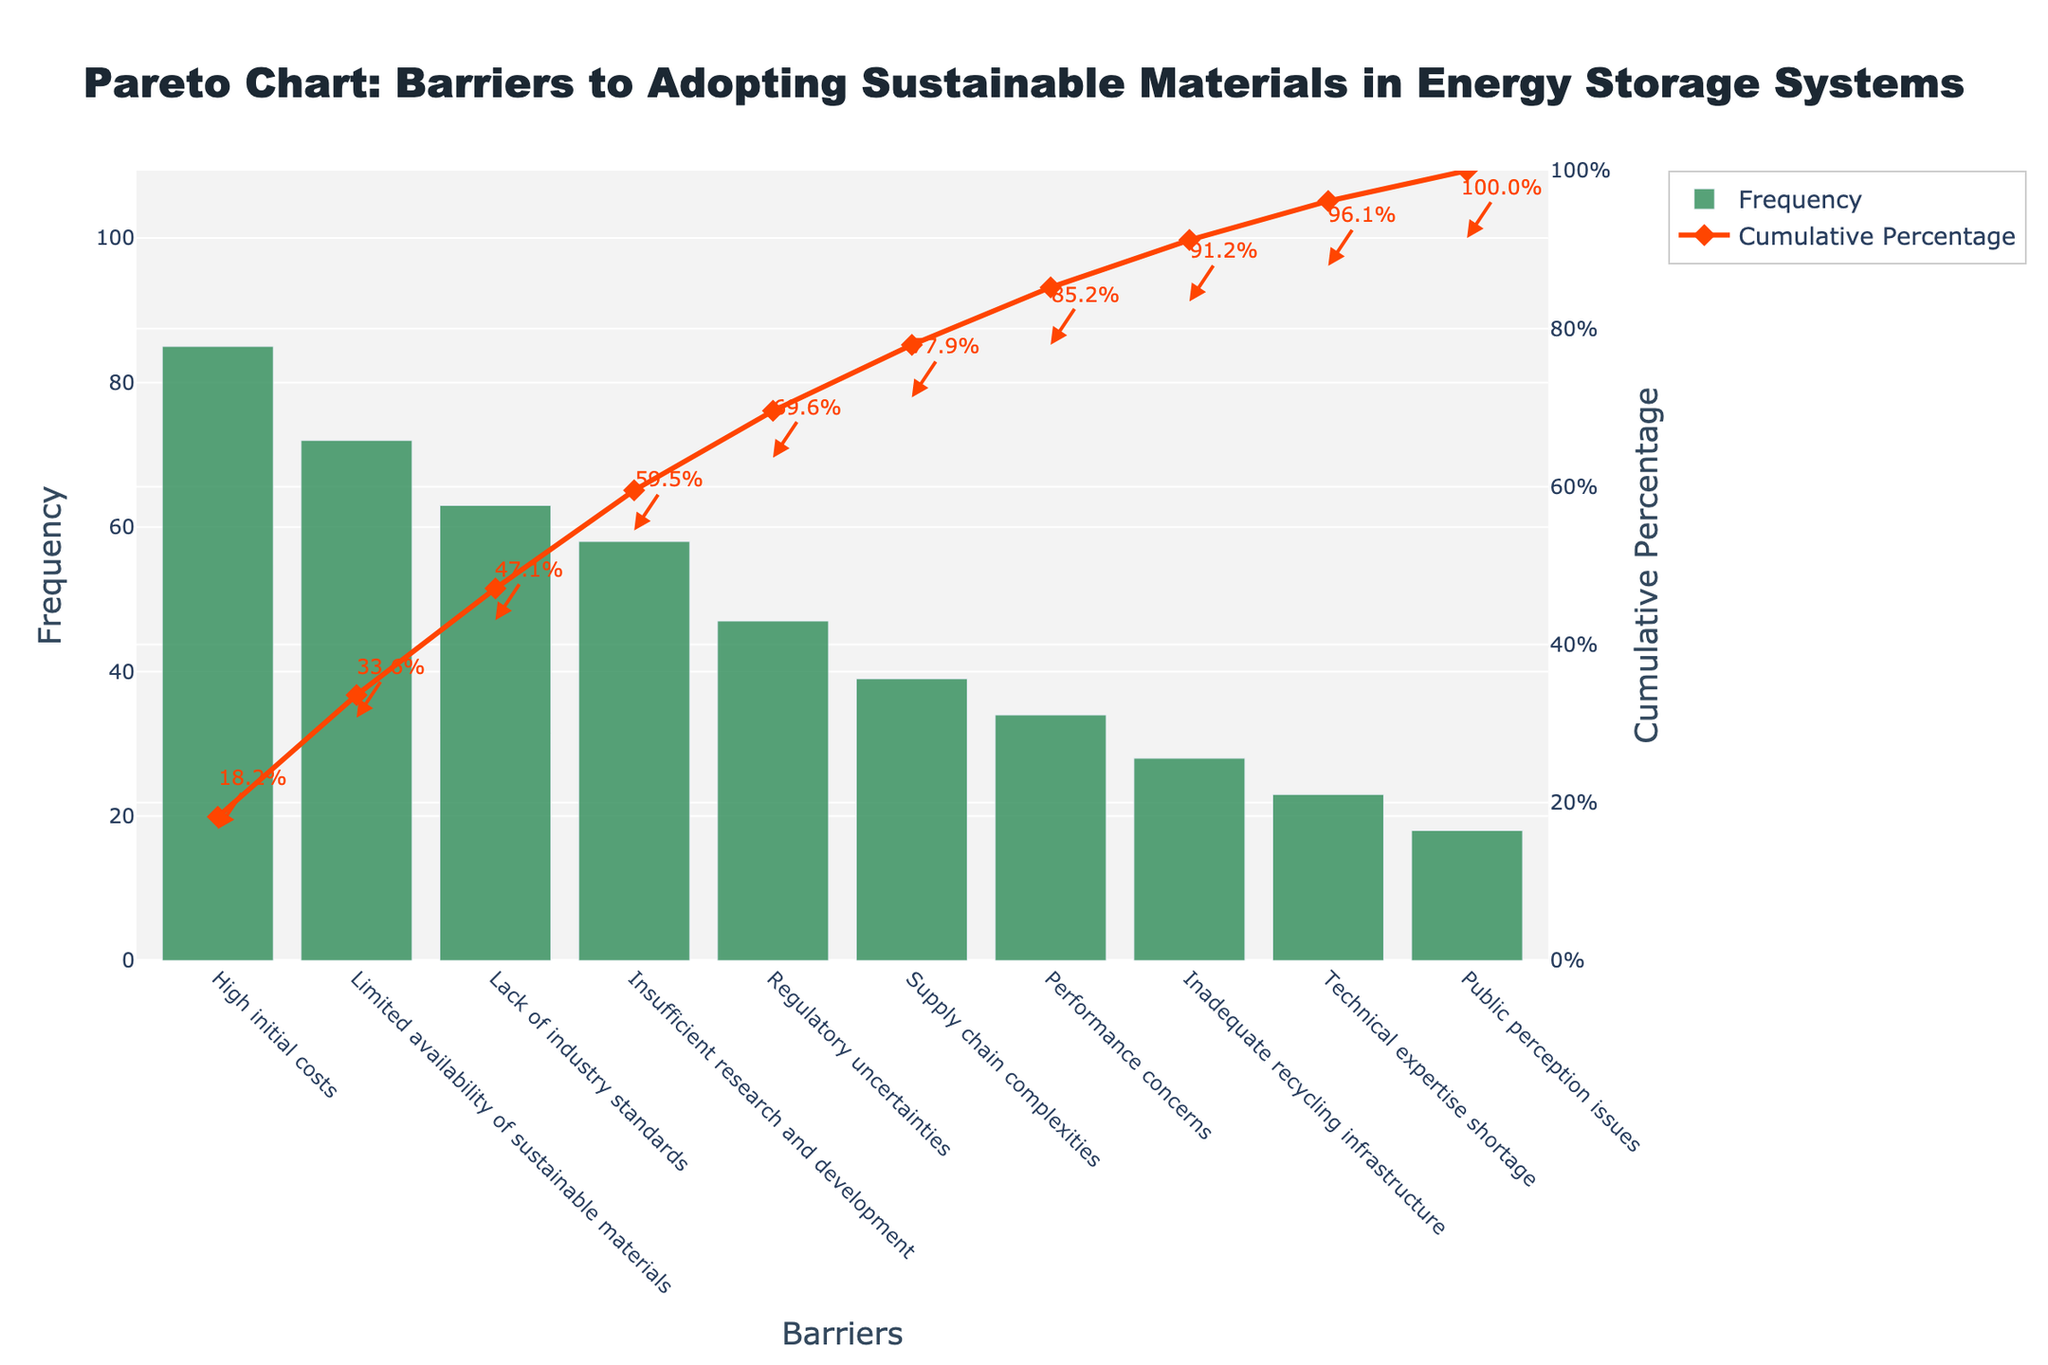What is the most significant barrier to adopting sustainable materials in energy storage systems? The highest bar on the Pareto chart represents the most significant barrier. "High initial costs" is the barrier with the highest frequency of 85.
Answer: High initial costs What is the cumulative percentage for the barrier "Limited availability of sustainable materials"? The cumulative percentage line indicates the cumulative impact up to each barrier. For “Limited availability of sustainable materials,” the cumulative percentage shown is around 42.5%.
Answer: 42.5% Which barrier is represented by the bar with the second highest frequency? The bars are arranged in descending order of frequency. The second bar represents "Limited availability of sustainable materials," which has a frequency of 72.
Answer: Limited availability of sustainable materials What is the sum of frequencies for "Regulatory uncertainties" and "Supply chain complexities"? From the data, the frequencies for "Regulatory uncertainties" and "Supply chain complexities" are 47 and 39, respectively. Summing these gives 86.
Answer: 86 How many barriers have a frequency greater than 50? By observing the bars, four barriers have frequencies greater than 50: “High initial costs,” “Limited availability of sustainable materials,” “Lack of industry standards,” and “Insufficient research and development.”
Answer: 4 Which barrier is represented at the cumulative percentage of around 60%? The cumulative percentage line crosses around 60% at the barrier "Insufficient research and development."
Answer: Insufficient research and development What is the difference in frequency between “High initial costs” and “Public perception issues”? The frequency of “High initial costs” is 85, and “Public perception issues” is 18. The difference is 85 - 18 = 67.
Answer: 67 Which barrier shows a cumulative percentage of approximately 90%? The cumulative percentage line reaches approximately 90% at the barrier "Inadequate recycling infrastructure."
Answer: Inadequate recycling infrastructure What is the average frequency of the top three barriers? The top three barriers are “High initial costs” (85), “Limited availability of sustainable materials” (72), and “Lack of industry standards” (63). The average frequency is (85 + 72 + 63) / 3 = 73.3.
Answer: 73.3 How many barriers are needed to reach a cumulative percentage of approximately 80%? The cumulative percentage line reaches around 80% after the sixth barrier, “Supply chain complexities.”
Answer: 6 